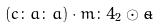Convert formula to latex. <formula><loc_0><loc_0><loc_500><loc_500>( c \colon a \colon a ) \cdot m \colon 4 _ { 2 } \odot \tilde { a }</formula> 